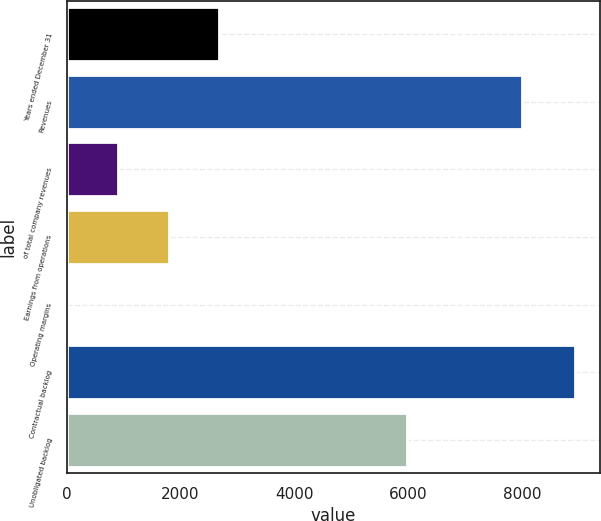Convert chart to OTSL. <chart><loc_0><loc_0><loc_500><loc_500><bar_chart><fcel>Years ended December 31<fcel>Revenues<fcel>of total company revenues<fcel>Earnings from operations<fcel>Operating margins<fcel>Contractual backlog<fcel>Unobligated backlog<nl><fcel>2686.59<fcel>8003<fcel>901.33<fcel>1793.96<fcel>8.7<fcel>8935<fcel>5987<nl></chart> 